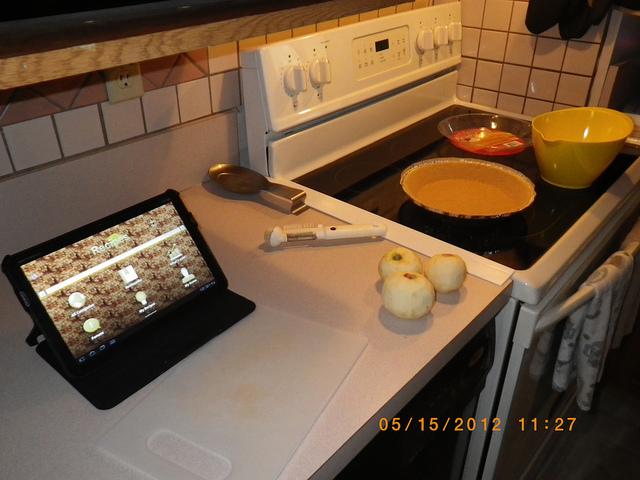What brand is the computer?
Keep it brief. Apple. What time was this picture taken?
Be succinct. 11:27. How many pink candles?
Answer briefly. 0. How many parts are on top of the stove?
Short answer required. 3. What is propped up on the counter?
Answer briefly. Tablet. What are the numbers are displayed?
Be succinct. Time and date. Is this a real stove?
Be succinct. Yes. Where are tiles?
Concise answer only. Wall. What color is the cutting board?
Be succinct. White. Is the countertop clean?
Quick response, please. Yes. How many species are on the counter?
Quick response, please. 0. Is this a real kitchen?
Short answer required. Yes. What brand is the oven?
Give a very brief answer. Kenmore. How many appliances are there?
Keep it brief. 1. What is the machine on the countertop?
Write a very short answer. Tablet. Is this a brand new appliance?
Be succinct. Yes. Is there a pan on the stove?
Short answer required. No. What color is the bowl?
Concise answer only. Yellow. What kind of pie is being made?
Keep it brief. Apple. What room of the house is this?
Keep it brief. Kitchen. 